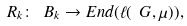<formula> <loc_0><loc_0><loc_500><loc_500>R _ { k } \colon \ B _ { k } \rightarrow E n d ( \ell ( \ G , \mu ) ) ,</formula> 